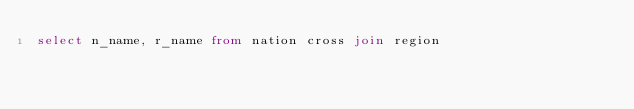Convert code to text. <code><loc_0><loc_0><loc_500><loc_500><_SQL_>select n_name, r_name from nation cross join region

</code> 